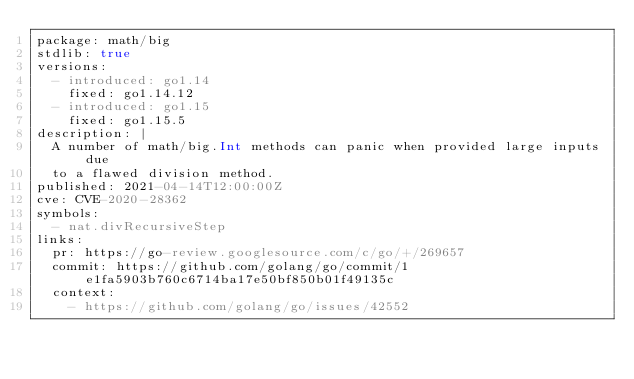Convert code to text. <code><loc_0><loc_0><loc_500><loc_500><_YAML_>package: math/big
stdlib: true
versions:
  - introduced: go1.14
    fixed: go1.14.12
  - introduced: go1.15
    fixed: go1.15.5
description: |
  A number of math/big.Int methods can panic when provided large inputs due
  to a flawed division method.
published: 2021-04-14T12:00:00Z
cve: CVE-2020-28362
symbols:
  - nat.divRecursiveStep
links:
  pr: https://go-review.googlesource.com/c/go/+/269657
  commit: https://github.com/golang/go/commit/1e1fa5903b760c6714ba17e50bf850b01f49135c
  context:
    - https://github.com/golang/go/issues/42552
</code> 